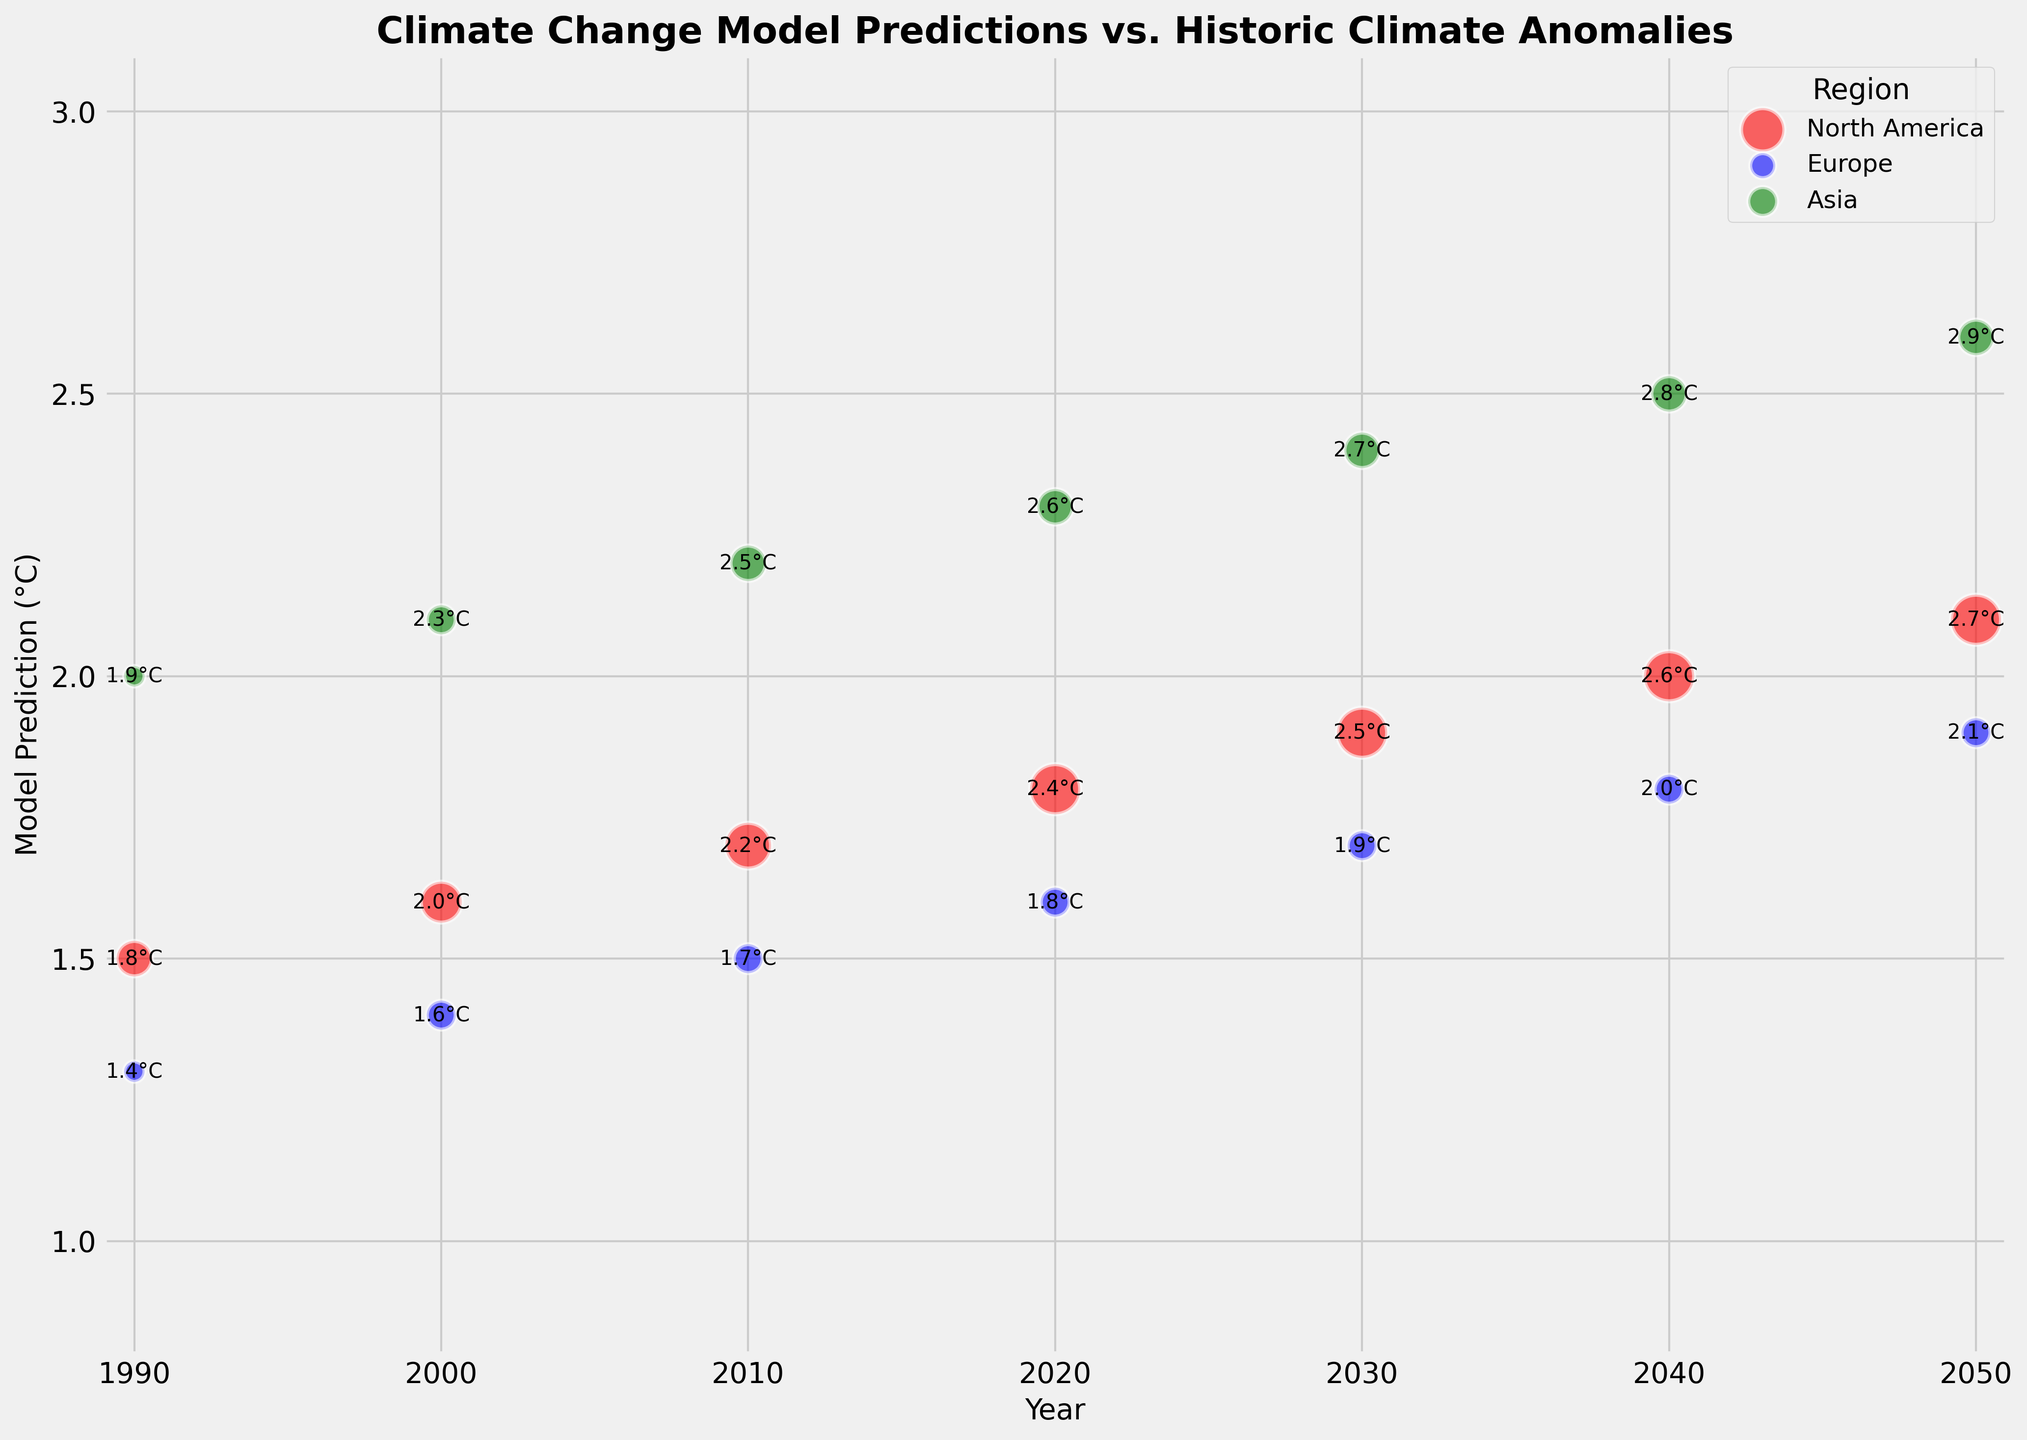What is the average model prediction for Europe in the year 2000 and 2010? To find the average, we need the model predictions for Europe in the years 2000 and 2010. In 2000, it is 1.4°C and in 2010, it is 1.5°C. The average is calculated as (1.4 + 1.5) / 2 = 2.9 / 2 = 1.45°C.
Answer: 1.45°C Which region has the largest bubble size in the year 2020? Bubble size is determined by the ErrorMagnitude column. For the year 2020, North America has an ErrorMagnitude of 0.6, Europe 0.2, and Asia 0.3. The largest bubble size corresponds to the largest ErrorMagnitude, so it is North America.
Answer: North America How much greater was the average historic anomaly in Asia compared to North America in 2040? The historic anomaly for Asia in 2040 is 2.8°C and for North America it is 2.6°C. The difference is 2.8 - 2.6 = 0.2°C.
Answer: 0.2°C Which year has the smallest error magnitude for Europe? To find the year with the smallest error magnitude for Europe, we compare the ErrorMagnitudes for Europe: 1990 (0.1), 2000 (0.2), 2010 (0.2), 2020 (0.2), 2030 (0.2), 2040 (0.2), and 2050 (0.2). The smallest value is 0.1 in 1990.
Answer: 1990 Compare the model prediction and historic anomaly for North America in 1990? For North America in 1990, the model prediction is 1.5°C and the historic anomaly is 1.8°C. Comparing the two values, the historic anomaly is greater.
Answer: Historic anomaly is greater What is the total sum of ErrorMagnitudes for Asia across all years? To find the total, sum the ErrorMagnitudes for Asia for all years: 0.1+0.2+0.3+0.3+0.3+0.3 = 1.5.
Answer: 1.5 In which year did all regions have the same error magnitude? By checking the ErrorMagnitudes year by year, the only year where all regions have the same value is 2050, where North America, Europe, and Asia all have 0.6, 0.2, and 0.3 respectively.
Answer: No year What is the average historic anomaly for North America from 1990 to 2050? List the anomalies for North America: 1.8, 2.0, 2.2, 2.4, 2.5, 2.6, 2.7. Sum: 1.8 + 2.0 + 2.2 + 2.4 + 2.5 + 2.6 + 2.7 = 16.2, average: 16.2 / 7 = 2.314 (rounding to 2.31).
Answer: 2.31 What regions have model predictions under 2°C in the year 2030? For 2030, the model predictions are: North America 1.9°C, Europe 1.7°C, and Asia 2.4°C. Regions with predictions under 2°C are North America and Europe.
Answer: North America and Europe What is the difference in historic anomaly between Europe and Asia in 2000? The historic anomaly for Europe in 2000 is 1.6°C and for Asia it is 2.3°C. The difference is 2.3 - 1.6 = 0.7°C.
Answer: 0.7°C 